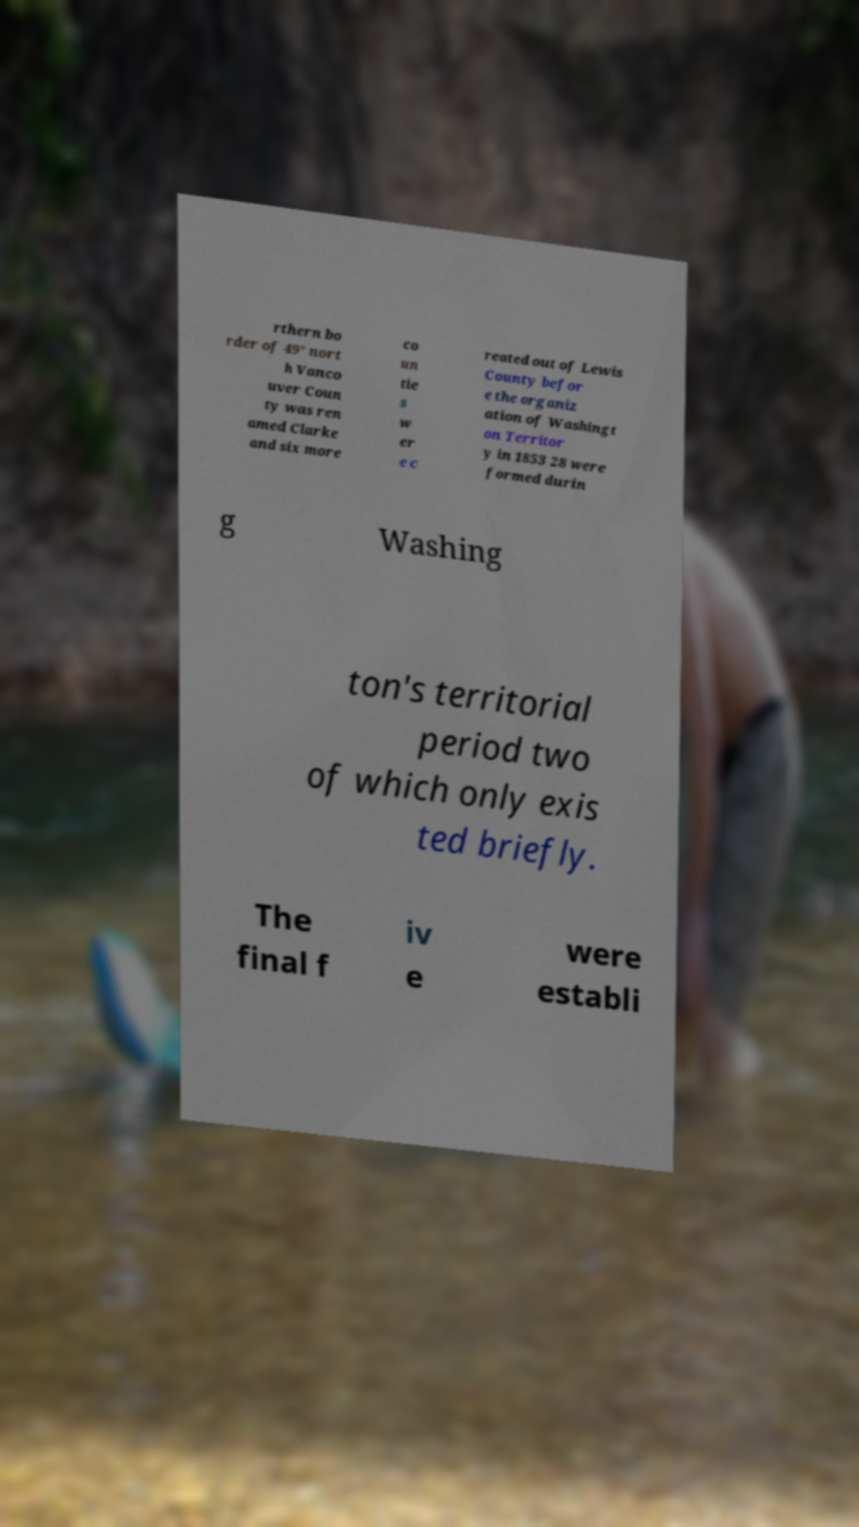Please identify and transcribe the text found in this image. rthern bo rder of 49° nort h Vanco uver Coun ty was ren amed Clarke and six more co un tie s w er e c reated out of Lewis County befor e the organiz ation of Washingt on Territor y in 1853 28 were formed durin g Washing ton's territorial period two of which only exis ted briefly. The final f iv e were establi 